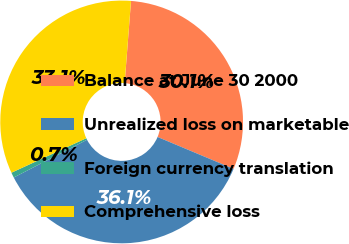<chart> <loc_0><loc_0><loc_500><loc_500><pie_chart><fcel>Balance at June 30 2000<fcel>Unrealized loss on marketable<fcel>Foreign currency translation<fcel>Comprehensive loss<nl><fcel>30.09%<fcel>36.11%<fcel>0.7%<fcel>33.1%<nl></chart> 